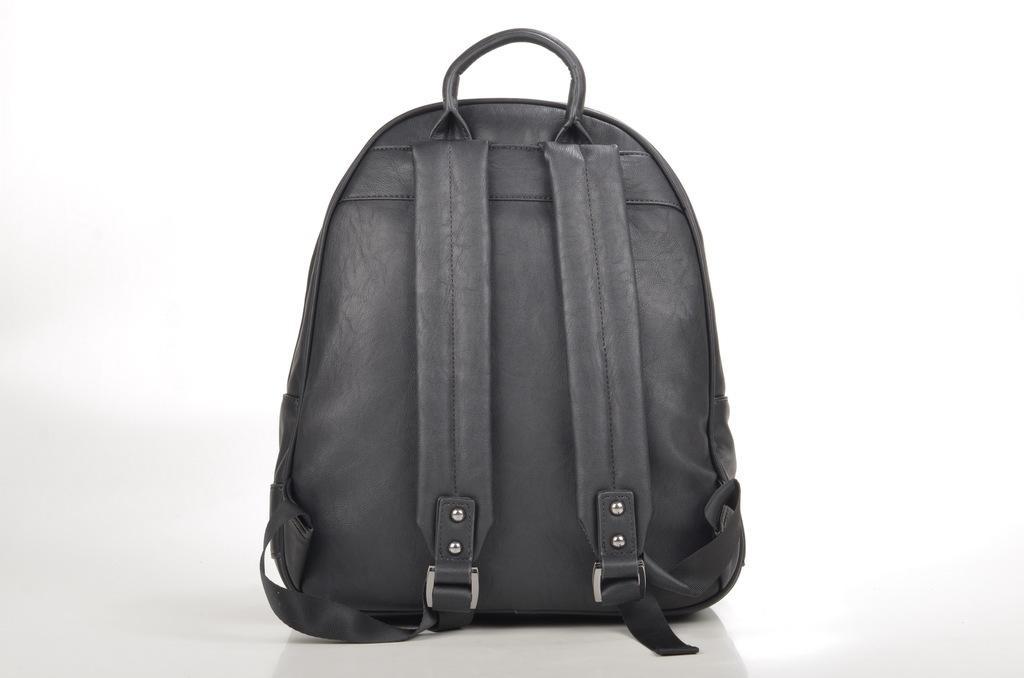Describe this image in one or two sentences. This image consists of a bag, it is a backpack. It is in black color. 